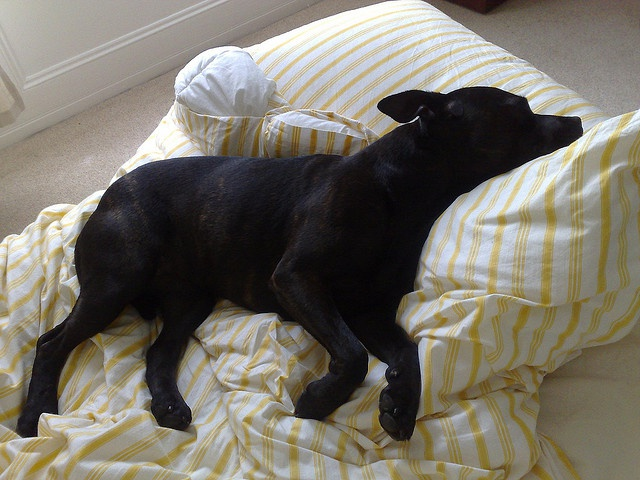Describe the objects in this image and their specific colors. I can see bed in black, lightgray, darkgray, and gray tones and dog in lightgray, black, gray, and olive tones in this image. 